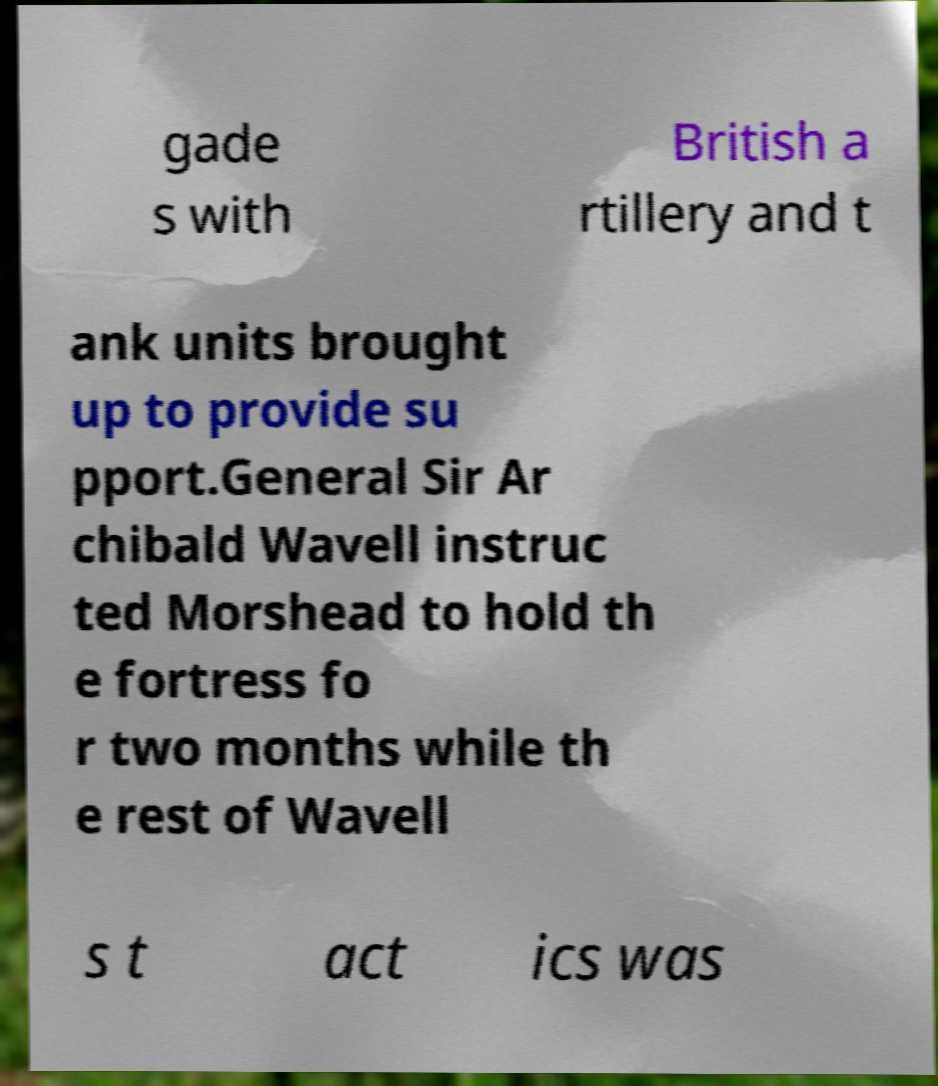Could you assist in decoding the text presented in this image and type it out clearly? gade s with British a rtillery and t ank units brought up to provide su pport.General Sir Ar chibald Wavell instruc ted Morshead to hold th e fortress fo r two months while th e rest of Wavell s t act ics was 